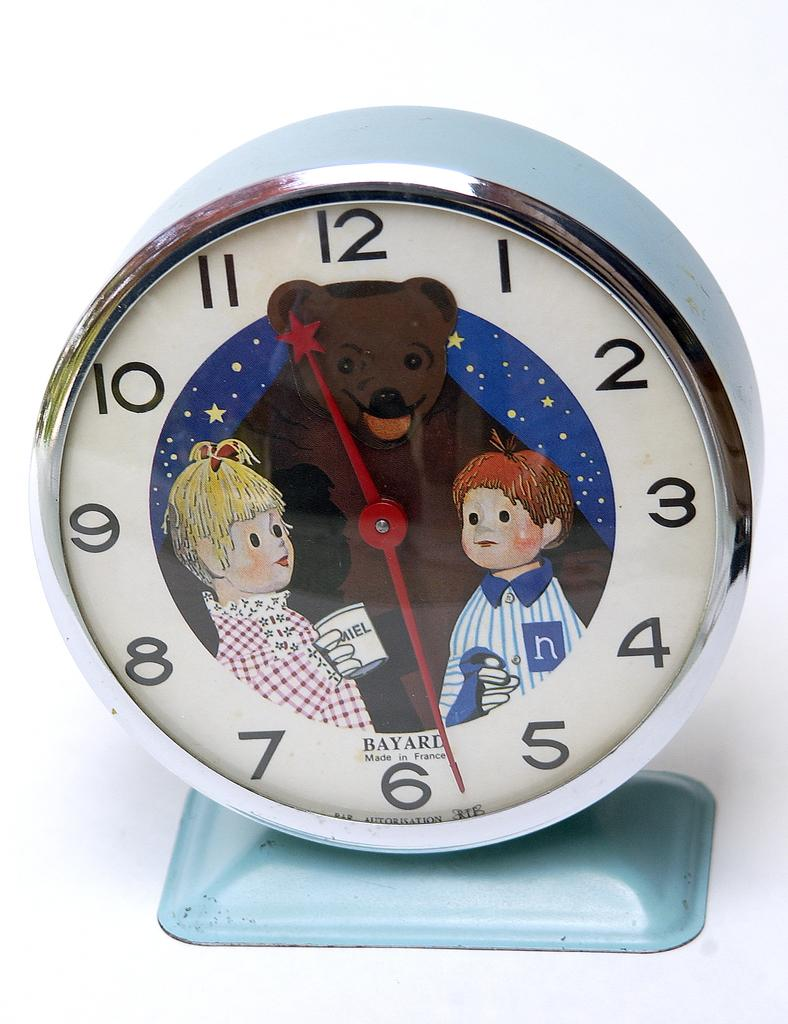<image>
Relay a brief, clear account of the picture shown. A children's Bayard clock has an image of a friendly bear, in between two small children and there is a star at the end of the hour arm. 